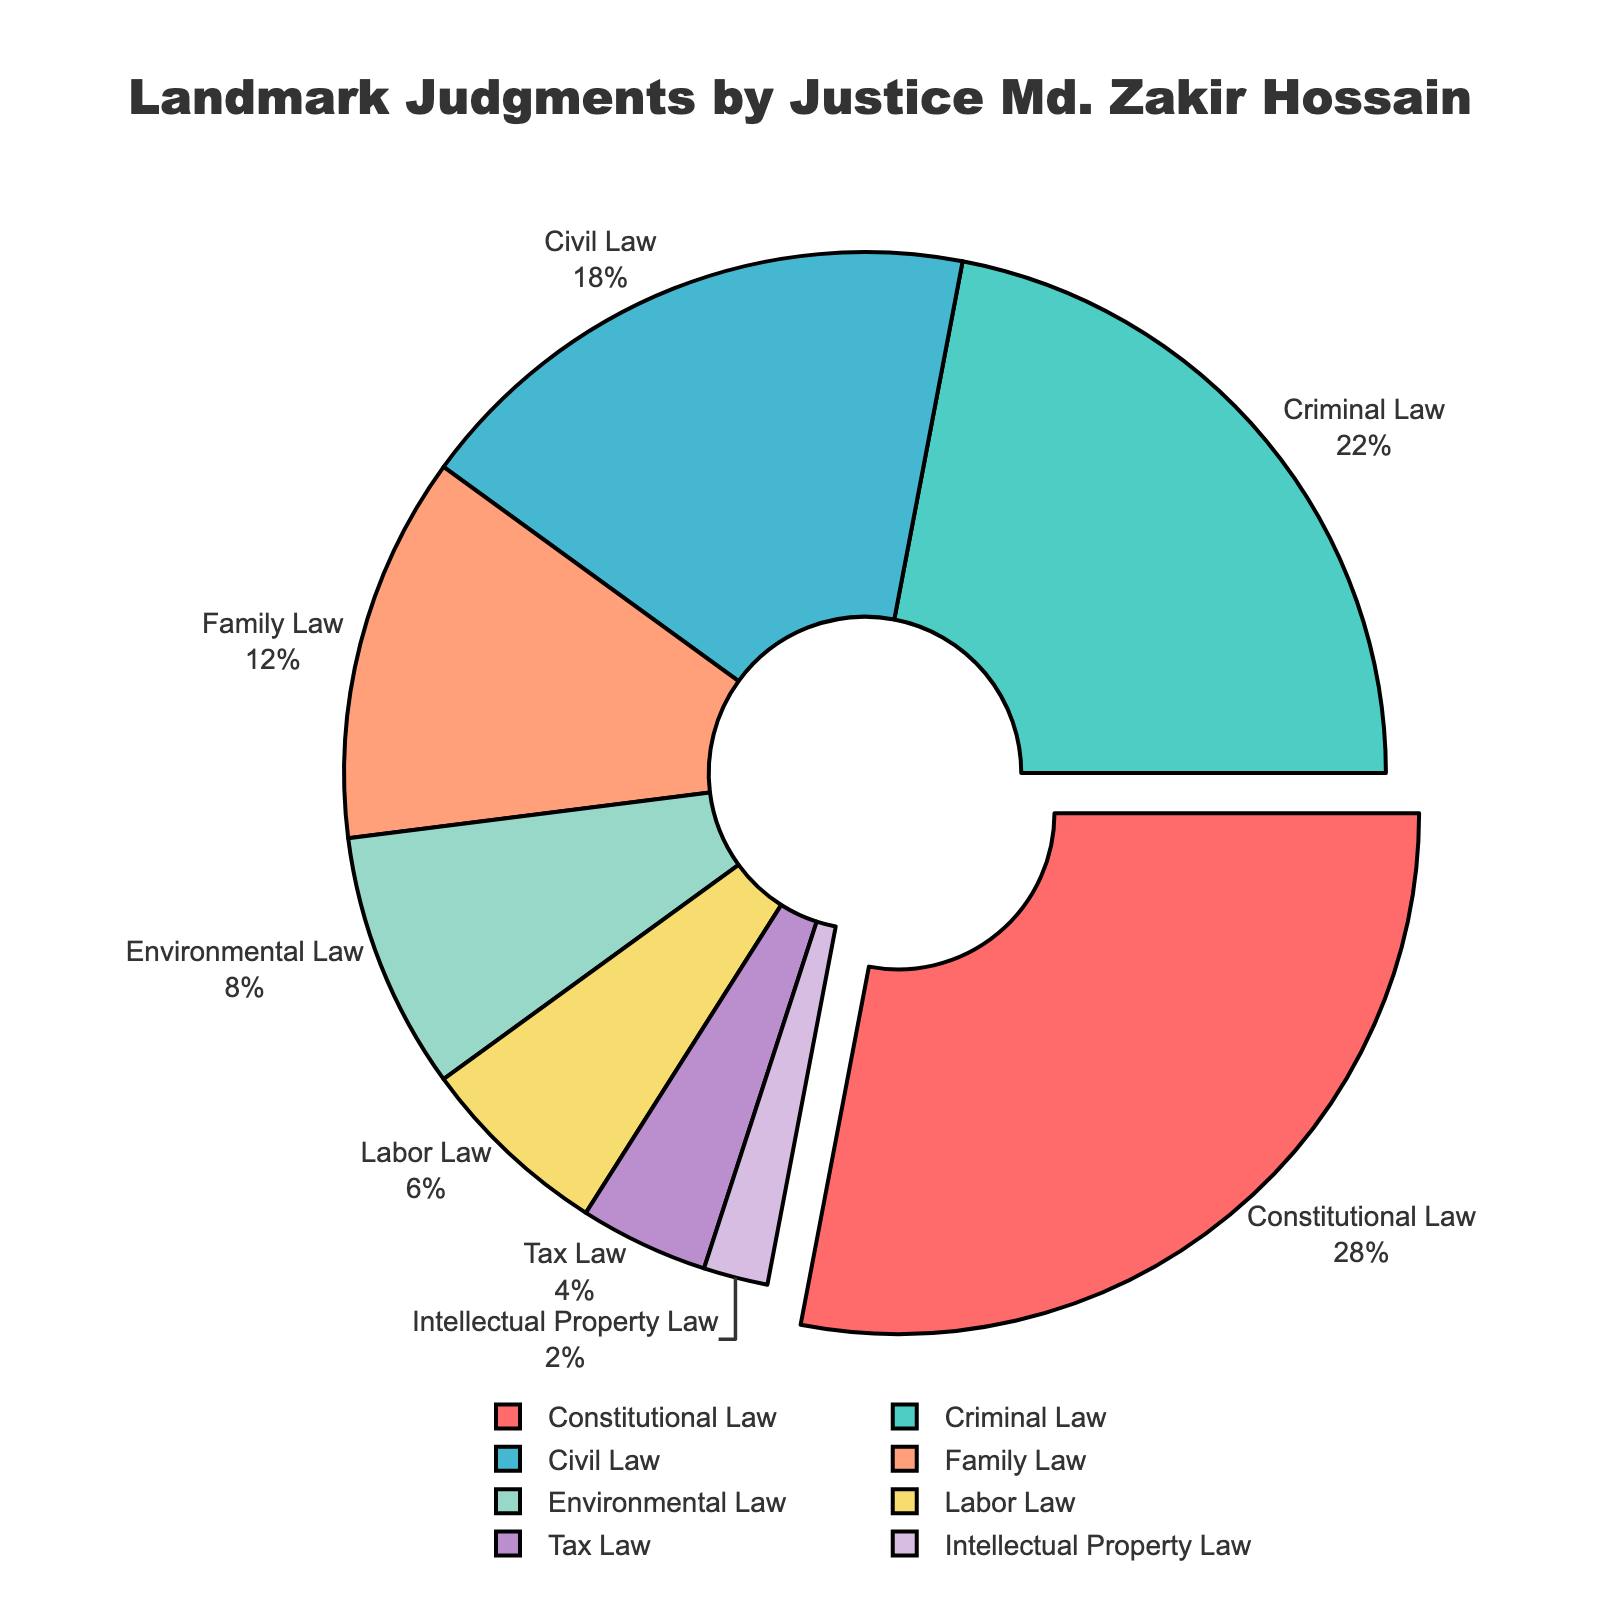what percentage of landmark judgments by Justice Md. Zakir Hossain are related to Constitutional Law? The pie chart shows the percentage breakdown for different areas of law. From the chart, we can see that Constitutional Law is indicated at 28%.
Answer: 28% which area of law has the second highest percentage of landmark judgments by Justice Md. Zakir Hossain? By looking at the pie chart, the areas of law and their corresponding percentages are displayed. The highest percentage is Constitutional Law (28%), and the second highest is Criminal Law (22%).
Answer: Criminal Law compare the combined percentage of landmark judgments for Civil Law and Family Law with Constitutional Law The percentages for Civil Law and Family Law are 18% and 12%, respectively. Summing them gives 18 + 12 = 30%. The percentage for Constitutional Law is 28%. Comparing them, 30% is greater than 28%.
Answer: Civil and Family Law combined is greater which area of law minimally contributes to the landmark judgments by Justice Md. Zakir Hossain? Observing the pie chart, we see that Intellectual Property Law has the smallest slice. Its percentage is 2%.
Answer: Intellectual Property Law how much less is the percentage of Environmental Law judgments compared to Constitutional Law? Constitutional Law judgments are 28%, and Environmental Law judgments are 8%. The difference is 28 - 8 = 20%.
Answer: 20% what are the color representations for the areas with the highest and lowest percentages? The chart uses different colors for various areas. Constitutional Law, the highest, is represented by red, and Intellectual Property Law, the lowest, is in violet.
Answer: Red for highest, Violet for lowest what is the total percentage for areas of law with percentages less than 10%? The areas with less than 10% are Environmental Law (8%), Labor Law (6%), Tax Law (4%), and Intellectual Property Law (2%). Adding them up: 8 + 6 + 4 + 2 = 20%.
Answer: 20% what portion of the pie chart is contributed by Labor Law and Tax Law combined? Labor Law is 6% and Tax Law is 4%. Their combined percentage is 6 + 4 = 10%.
Answer: 10% how many areas of law have a percentage of 10% or more in landmark judgments? By examining the chart, we can see Constitutional Law (28%), Criminal Law (22%), Civil Law (18%), and Family Law (12%) all have percentages of 10% or more. There are 4 such areas.
Answer: 4 areas which area of law is represented by the color green, and what percentage does it have? From the pie chart, we can see that the color green represents Criminal Law, which contributes 22% to the landmark judgments.
Answer: Criminal Law, 22% 